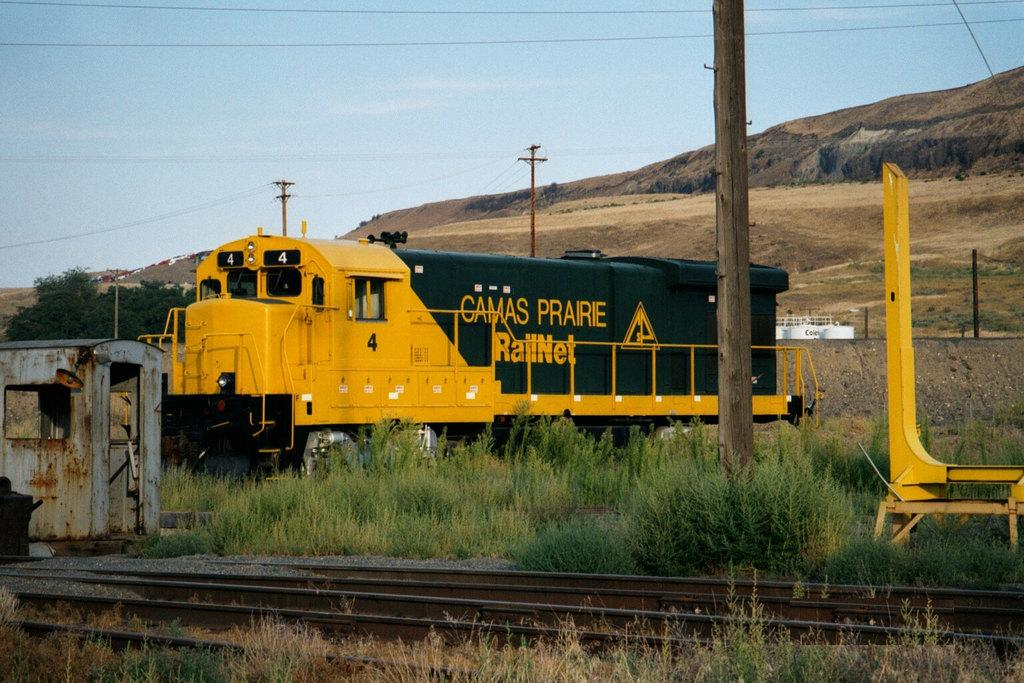<image>
Present a compact description of the photo's key features. A train engine is sitting on a track and the word Camas is written on it. 